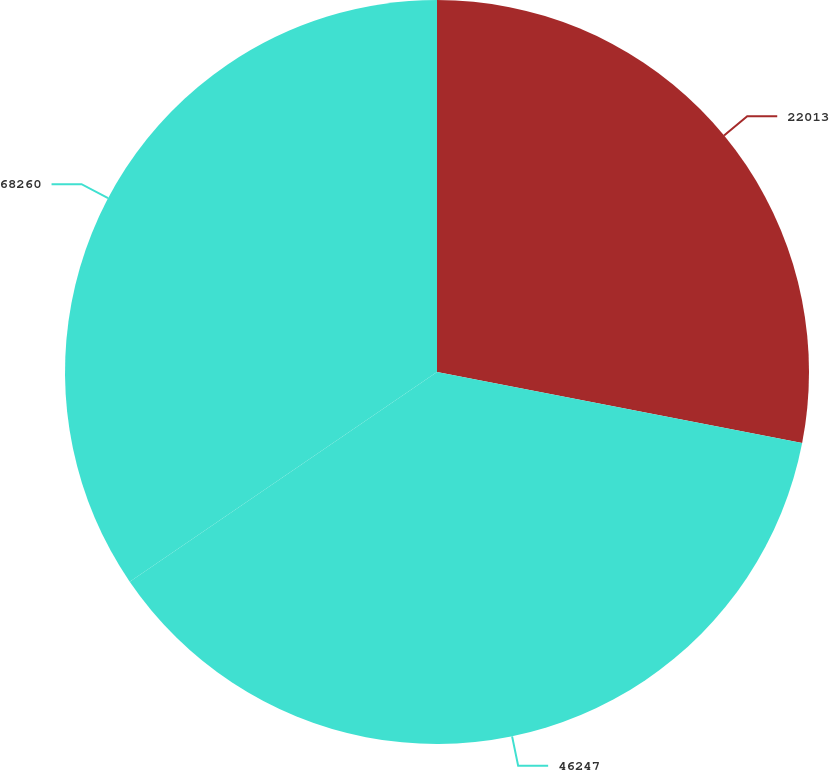Convert chart to OTSL. <chart><loc_0><loc_0><loc_500><loc_500><pie_chart><fcel>22013<fcel>46247<fcel>68260<nl><fcel>28.06%<fcel>37.41%<fcel>34.53%<nl></chart> 